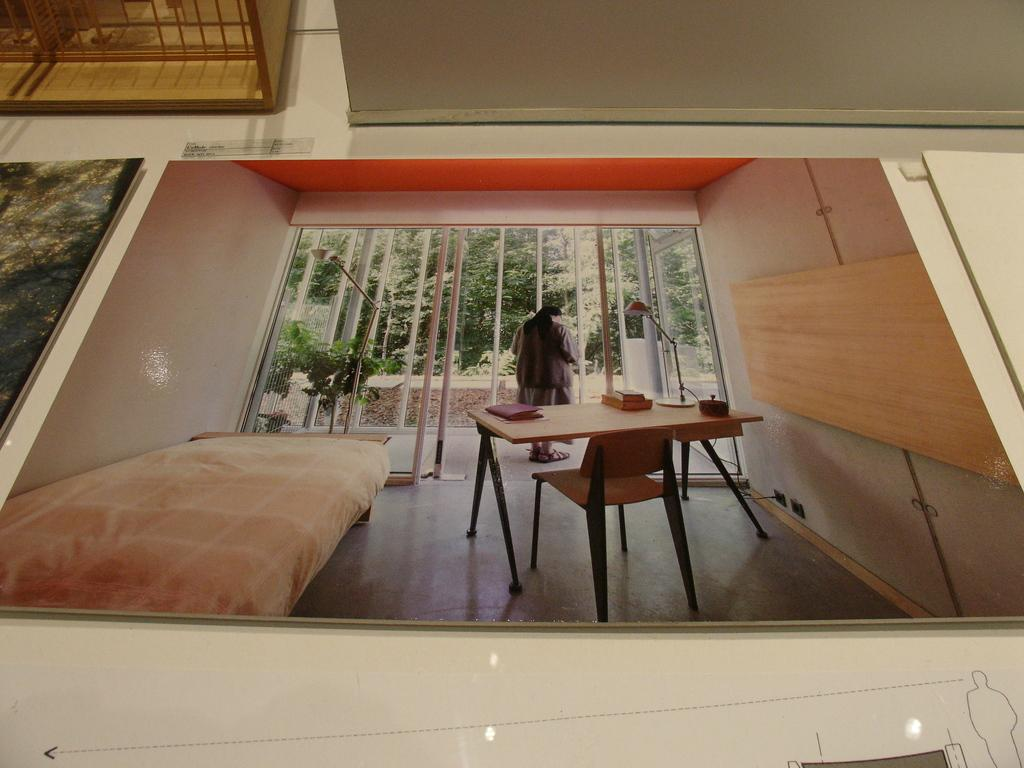What can be seen on the posts in the image? There are posts with images in the image. What is the surface on which the posts are placed? The posts are placed on a surface. What is placed on top of the posts? There are objects on top of the posts. What type of religious symbol can be seen on the sock in the image? There is no sock or religious symbol present in the image. 